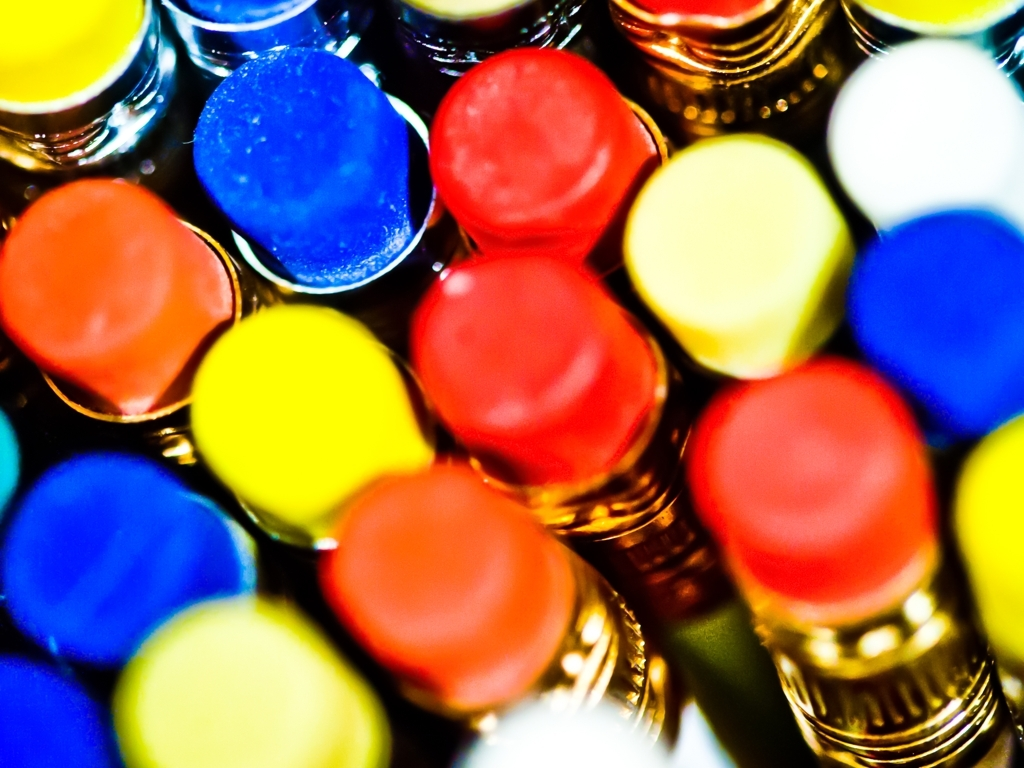Could this picture be used for educational purposes? Certainly, this image could be utilized in educational settings to discuss concepts such as color theory, the emotional impact of colors, and the use of focus in photography. The distinctive separation of colors makes it a great visual tool for illustrating primary and secondary colors as well as complementary color pairings. 